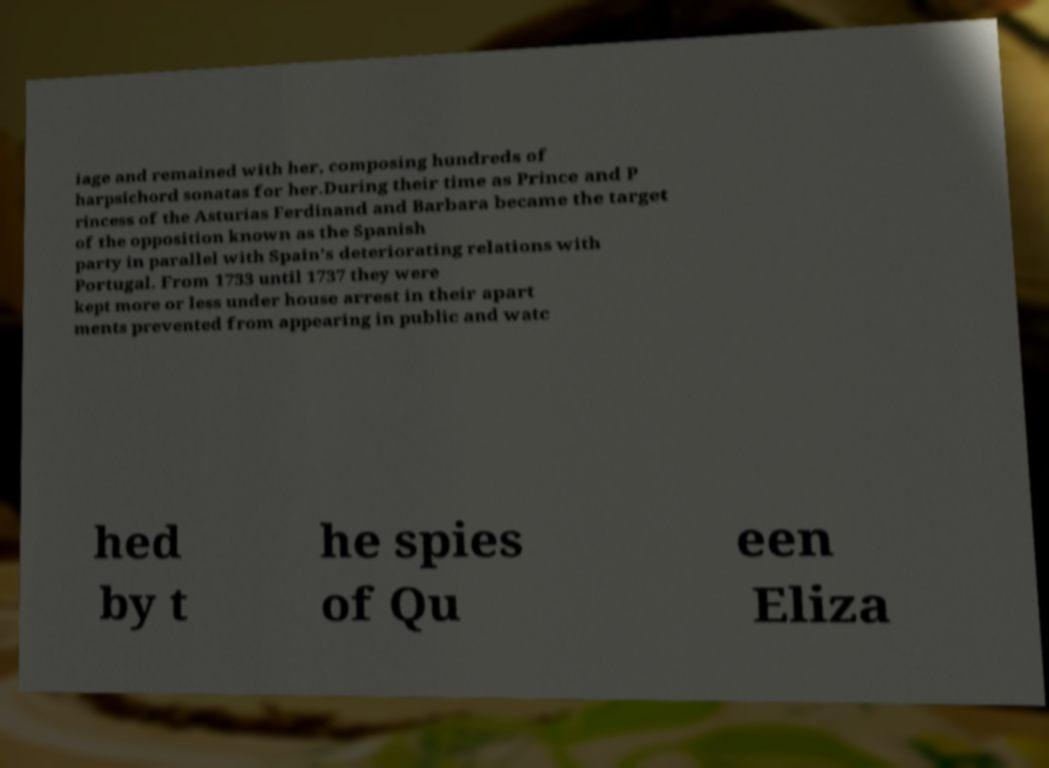Please read and relay the text visible in this image. What does it say? iage and remained with her, composing hundreds of harpsichord sonatas for her.During their time as Prince and P rincess of the Asturias Ferdinand and Barbara became the target of the opposition known as the Spanish party in parallel with Spain's deteriorating relations with Portugal. From 1733 until 1737 they were kept more or less under house arrest in their apart ments prevented from appearing in public and watc hed by t he spies of Qu een Eliza 